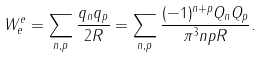Convert formula to latex. <formula><loc_0><loc_0><loc_500><loc_500>W _ { e } ^ { e } = \sum _ { n , p } \frac { q _ { n } q _ { p } } { 2 R } = \sum _ { n , p } \frac { ( - 1 ) ^ { n + p } Q _ { n } Q _ { p } } { \pi ^ { 3 } n p R } .</formula> 